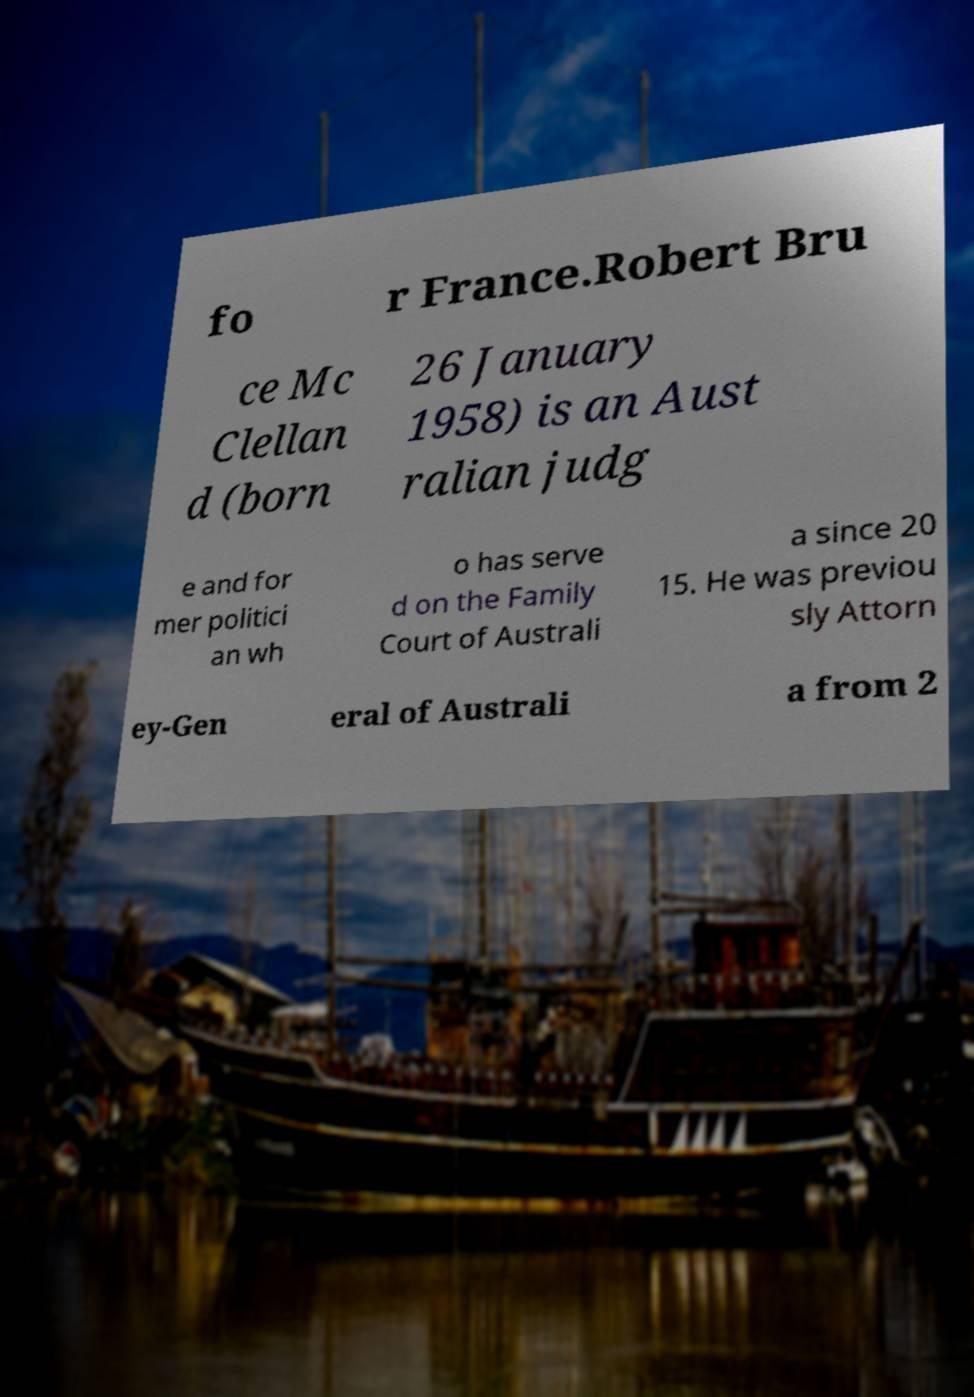Please identify and transcribe the text found in this image. fo r France.Robert Bru ce Mc Clellan d (born 26 January 1958) is an Aust ralian judg e and for mer politici an wh o has serve d on the Family Court of Australi a since 20 15. He was previou sly Attorn ey-Gen eral of Australi a from 2 